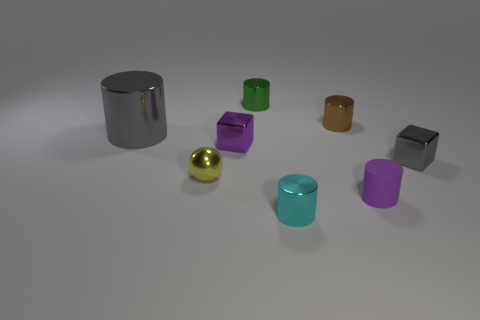Subtract all gray metal cylinders. How many cylinders are left? 4 Subtract all purple blocks. How many blocks are left? 1 Add 1 balls. How many objects exist? 9 Subtract all cylinders. How many objects are left? 3 Subtract all red cylinders. Subtract all blue spheres. How many cylinders are left? 5 Subtract 1 green cylinders. How many objects are left? 7 Subtract 1 blocks. How many blocks are left? 1 Subtract all blue cubes. How many purple cylinders are left? 1 Subtract all small purple metallic cubes. Subtract all small green metal things. How many objects are left? 6 Add 8 green objects. How many green objects are left? 9 